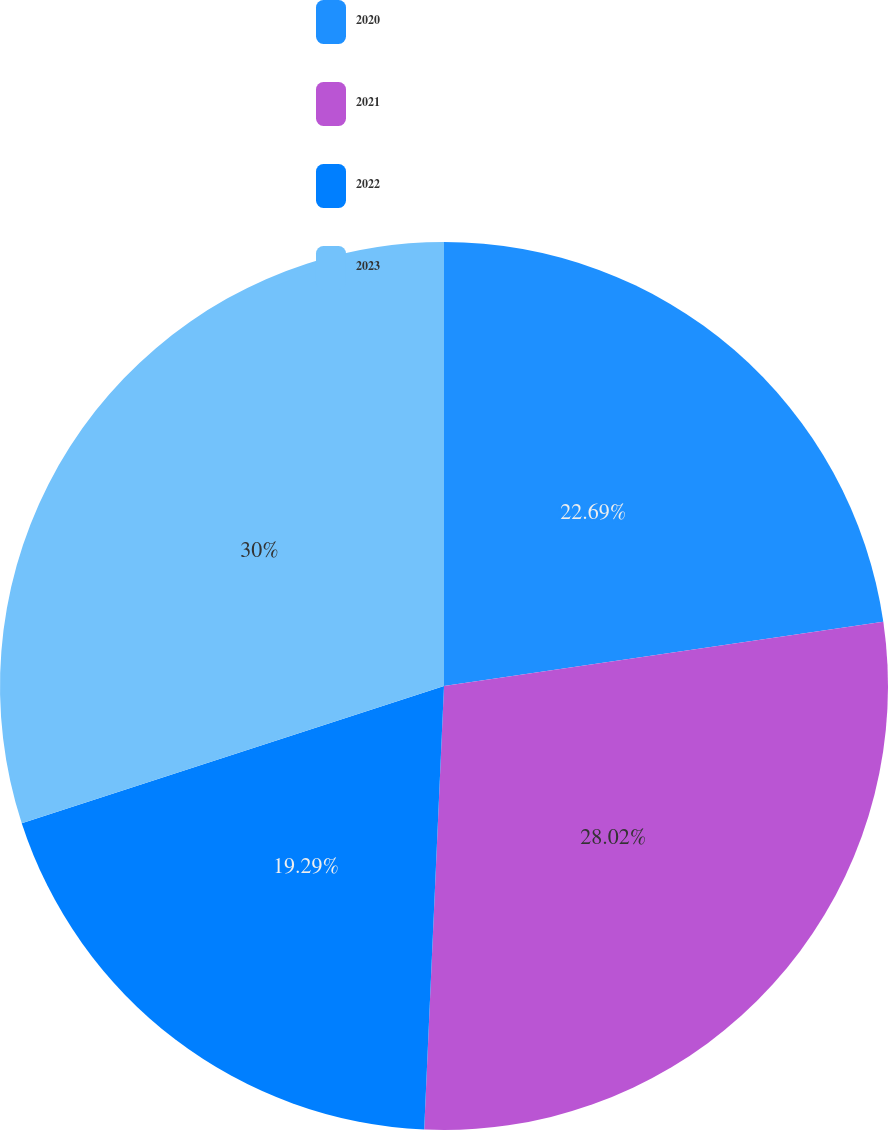Convert chart. <chart><loc_0><loc_0><loc_500><loc_500><pie_chart><fcel>2020<fcel>2021<fcel>2022<fcel>2023<nl><fcel>22.69%<fcel>28.02%<fcel>19.29%<fcel>30.0%<nl></chart> 